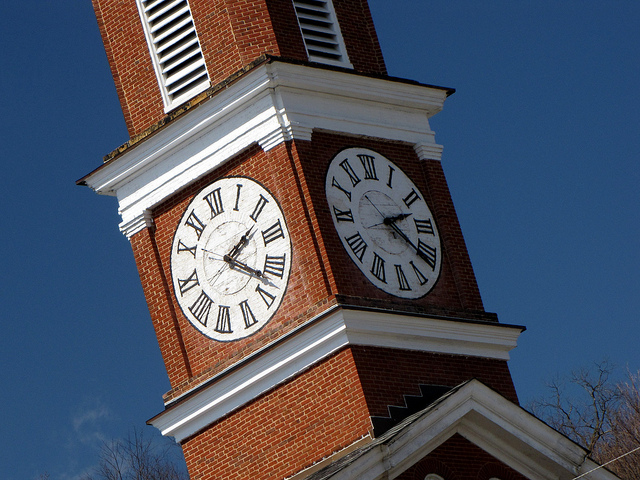Identify and read out the text in this image. XII VIII XII XI IIII I XI X XI II III IIV V IV VII XI X VIII VII VI V III II I 